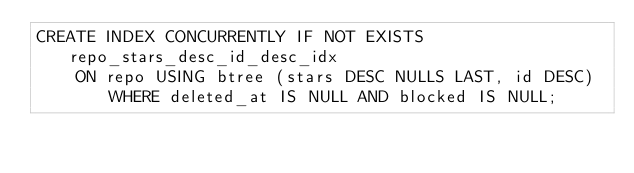<code> <loc_0><loc_0><loc_500><loc_500><_SQL_>CREATE INDEX CONCURRENTLY IF NOT EXISTS repo_stars_desc_id_desc_idx
    ON repo USING btree (stars DESC NULLS LAST, id DESC) WHERE deleted_at IS NULL AND blocked IS NULL;
</code> 